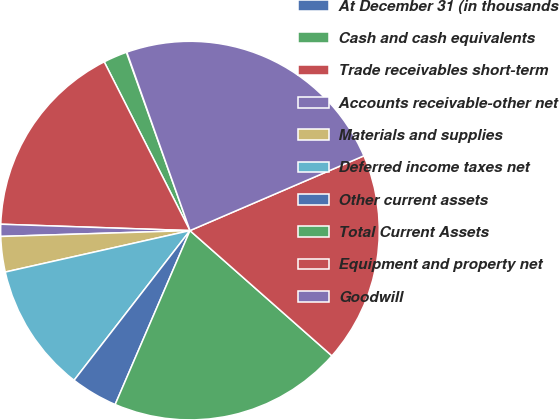<chart> <loc_0><loc_0><loc_500><loc_500><pie_chart><fcel>At December 31 (in thousands<fcel>Cash and cash equivalents<fcel>Trade receivables short-term<fcel>Accounts receivable-other net<fcel>Materials and supplies<fcel>Deferred income taxes net<fcel>Other current assets<fcel>Total Current Assets<fcel>Equipment and property net<fcel>Goodwill<nl><fcel>0.04%<fcel>2.03%<fcel>16.98%<fcel>1.03%<fcel>3.02%<fcel>11.0%<fcel>4.02%<fcel>19.96%<fcel>17.97%<fcel>23.95%<nl></chart> 